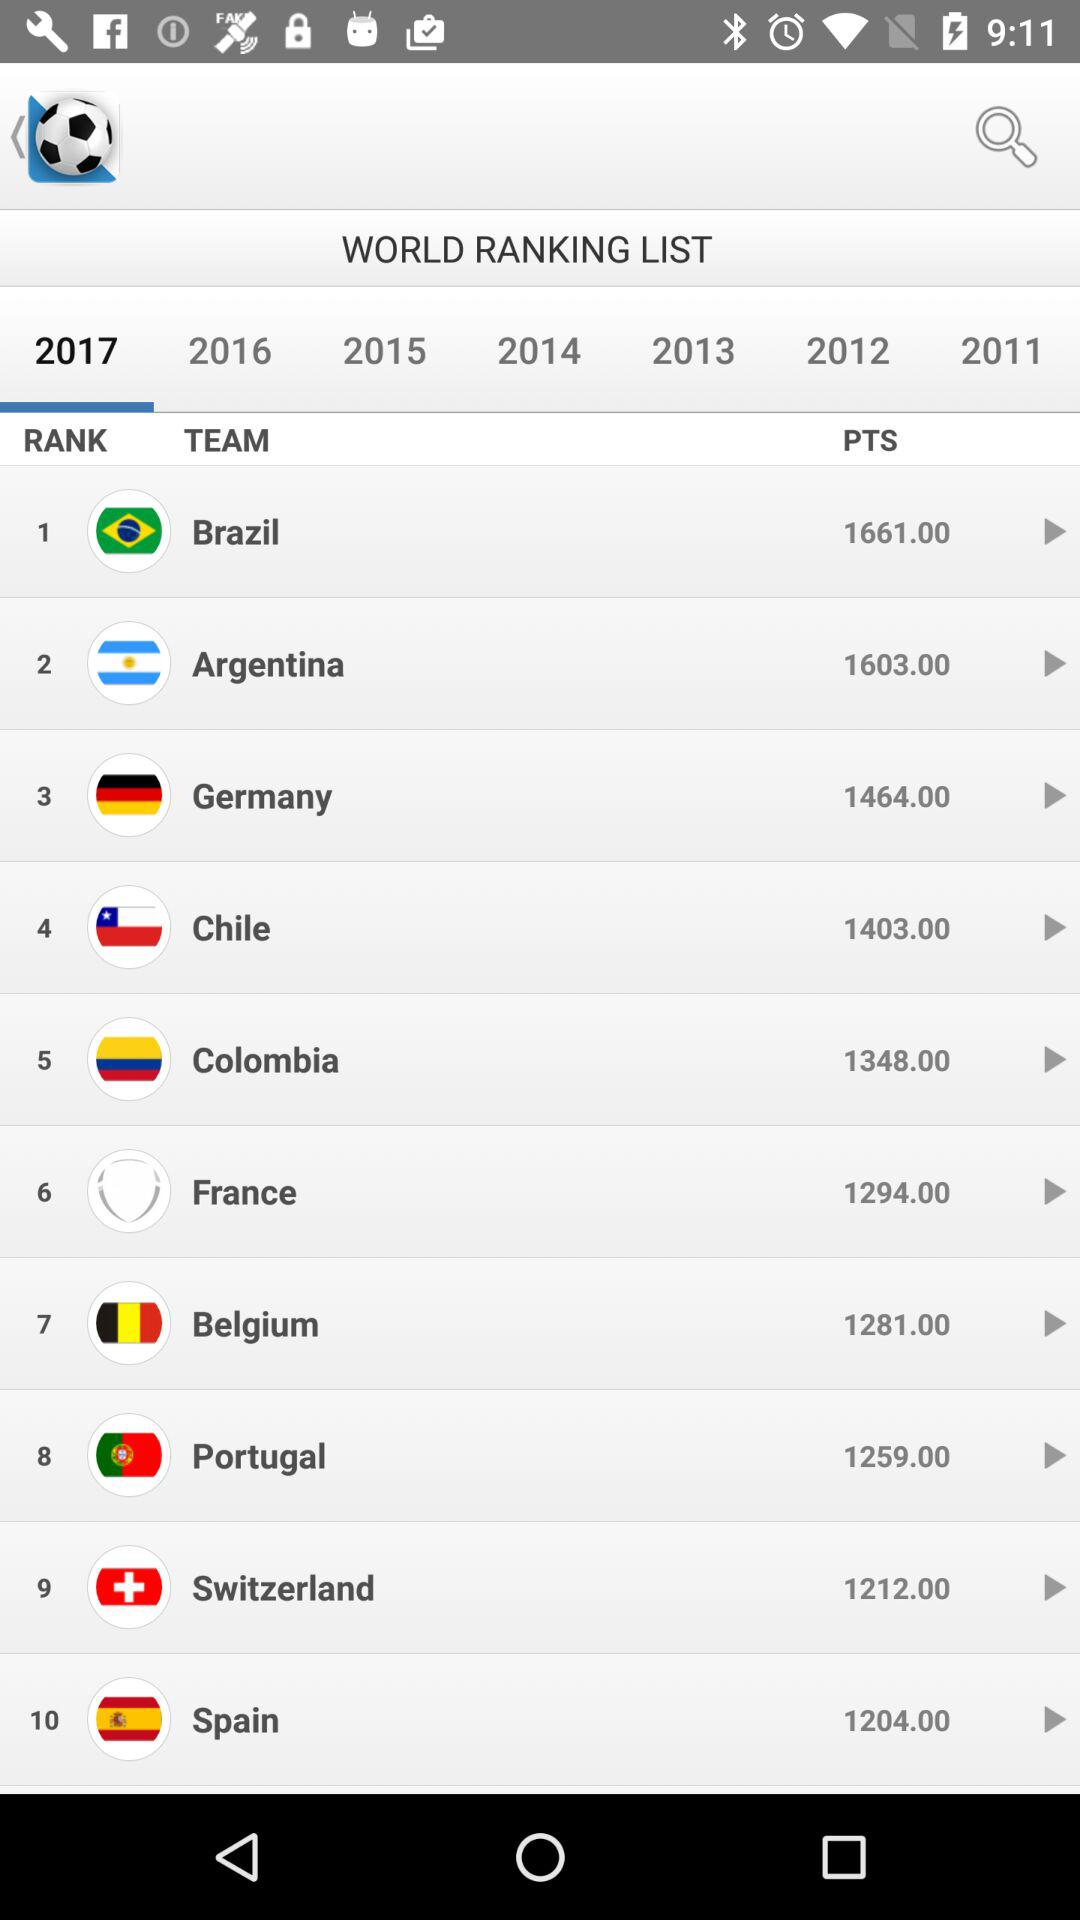Which team has 1212 points? The team is "Switzerland". 